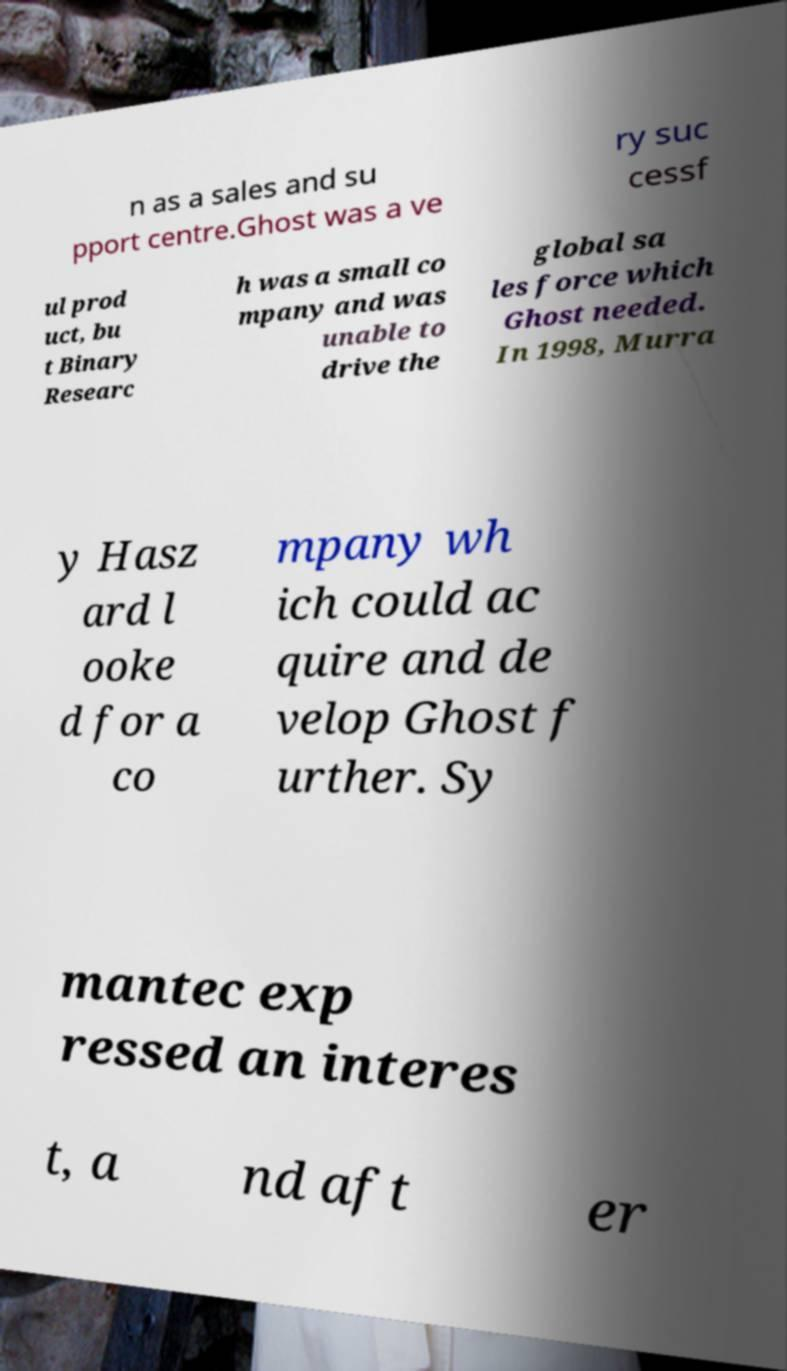Please identify and transcribe the text found in this image. n as a sales and su pport centre.Ghost was a ve ry suc cessf ul prod uct, bu t Binary Researc h was a small co mpany and was unable to drive the global sa les force which Ghost needed. In 1998, Murra y Hasz ard l ooke d for a co mpany wh ich could ac quire and de velop Ghost f urther. Sy mantec exp ressed an interes t, a nd aft er 